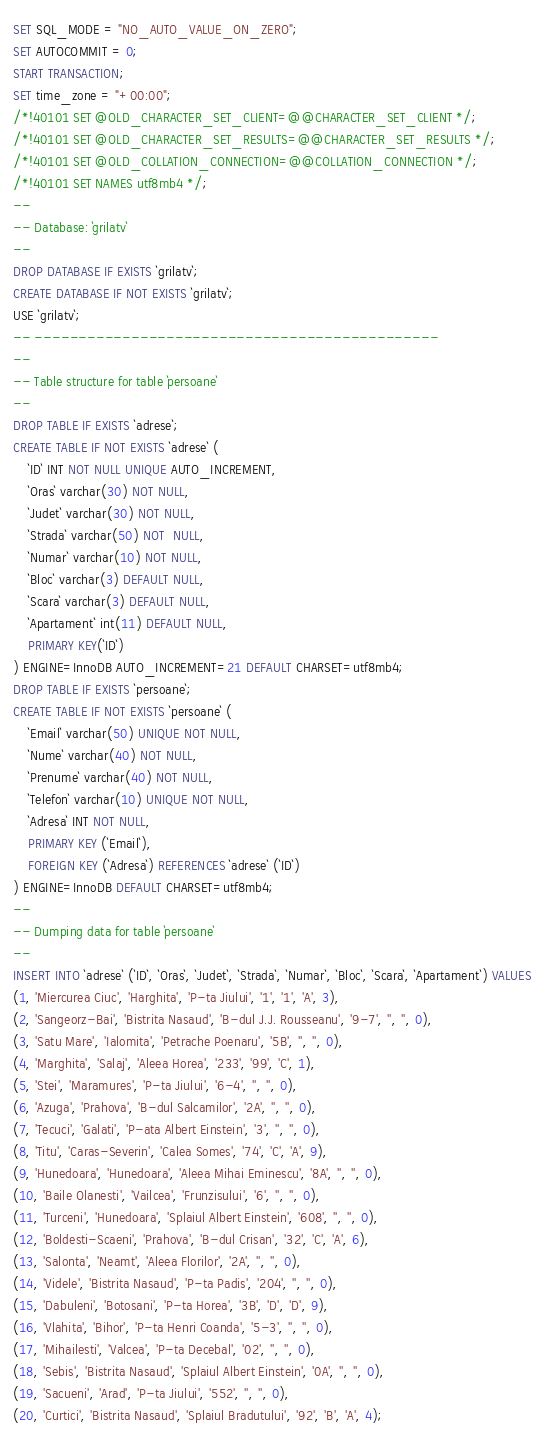Convert code to text. <code><loc_0><loc_0><loc_500><loc_500><_SQL_>SET SQL_MODE = "NO_AUTO_VALUE_ON_ZERO";
SET AUTOCOMMIT = 0;
START TRANSACTION;
SET time_zone = "+00:00";
/*!40101 SET @OLD_CHARACTER_SET_CLIENT=@@CHARACTER_SET_CLIENT */;
/*!40101 SET @OLD_CHARACTER_SET_RESULTS=@@CHARACTER_SET_RESULTS */;
/*!40101 SET @OLD_COLLATION_CONNECTION=@@COLLATION_CONNECTION */;
/*!40101 SET NAMES utf8mb4 */;
--
-- Database: `grilatv` 
--
DROP DATABASE IF EXISTS `grilatv`;
CREATE DATABASE IF NOT EXISTS `grilatv`;
USE `grilatv`;
-- ----------------------------------------------
--
-- Table structure for table `persoane`
--
DROP TABLE IF EXISTS `adrese`;
CREATE TABLE IF NOT EXISTS `adrese` (
    `ID` INT NOT NULL UNIQUE AUTO_INCREMENT,
    `Oras` varchar(30) NOT NULL,
    `Judet` varchar(30) NOT NULL,
    `Strada` varchar(50) NOT  NULL,
    `Numar` varchar(10) NOT NULL,
    `Bloc` varchar(3) DEFAULT NULL,
    `Scara` varchar(3) DEFAULT NULL,
    `Apartament` int(11) DEFAULT NULL,
    PRIMARY KEY(`ID`)
) ENGINE=InnoDB AUTO_INCREMENT=21 DEFAULT CHARSET=utf8mb4;
DROP TABLE IF EXISTS `persoane`;
CREATE TABLE IF NOT EXISTS `persoane` (
    `Email` varchar(50) UNIQUE NOT NULL,
    `Nume` varchar(40) NOT NULL,
    `Prenume` varchar(40) NOT NULL,
    `Telefon` varchar(10) UNIQUE NOT NULL,
    `Adresa` INT NOT NULL,
    PRIMARY KEY (`Email`),
    FOREIGN KEY (`Adresa`) REFERENCES `adrese` (`ID`)
) ENGINE=InnoDB DEFAULT CHARSET=utf8mb4;
--
-- Dumping data for table `persoane`
--
INSERT INTO `adrese` (`ID`, `Oras`, `Judet`, `Strada`, `Numar`, `Bloc`, `Scara`, `Apartament`) VALUES 
(1, 'Miercurea Ciuc', 'Harghita', 'P-ta Jiului', '1', '1', 'A', 3),
(2, 'Sangeorz-Bai', 'Bistrita Nasaud', 'B-dul J.J. Rousseanu', '9-7', '', '', 0),
(3, 'Satu Mare', 'Ialomita', 'Petrache Poenaru', '5B', '', '', 0),
(4, 'Marghita', 'Salaj', 'Aleea Horea', '233', '99', 'C', 1),
(5, 'Stei', 'Maramures', 'P-ta Jiului', '6-4', '', '', 0),
(6, 'Azuga', 'Prahova', 'B-dul Salcamilor', '2A', '', '', 0),
(7, 'Tecuci', 'Galati', 'P-ata Albert Einstein', '3', '', '', 0),
(8, 'Titu', 'Caras-Severin', 'Calea Somes', '74', 'C', 'A', 9),
(9, 'Hunedoara', 'Hunedoara', 'Aleea Mihai Eminescu', '8A', '', '', 0),
(10, 'Baile Olanesti', 'Vailcea', 'Frunzisului', '6', '', '', 0),
(11, 'Turceni', 'Hunedoara', 'Splaiul Albert Einstein', '608', '', '', 0),
(12, 'Boldesti-Scaeni', 'Prahova', 'B-dul Crisan', '32', 'C', 'A', 6),
(13, 'Salonta', 'Neamt', 'Aleea Florilor', '2A', '', '', 0),
(14, 'Videle', 'Bistrita Nasaud', 'P-ta Padis', '204', '', '', 0),
(15, 'Dabuleni', 'Botosani', 'P-ta Horea', '3B', 'D', 'D', 9),
(16, 'Vlahita', 'Bihor', 'P-ta Henri Coanda', '5-3', '', '', 0),
(17, 'Mihailesti', 'Valcea', 'P-ta Decebal', '02', '', '', 0),
(18, 'Sebis', 'Bistrita Nasaud', 'Splaiul Albert Einstein', '0A', '', '', 0),
(19, 'Sacueni', 'Arad', 'P-ta Jiului', '552', '', '', 0),
(20, 'Curtici', 'Bistrita Nasaud', 'Splaiul Bradutului', '92', 'B', 'A', 4);</code> 